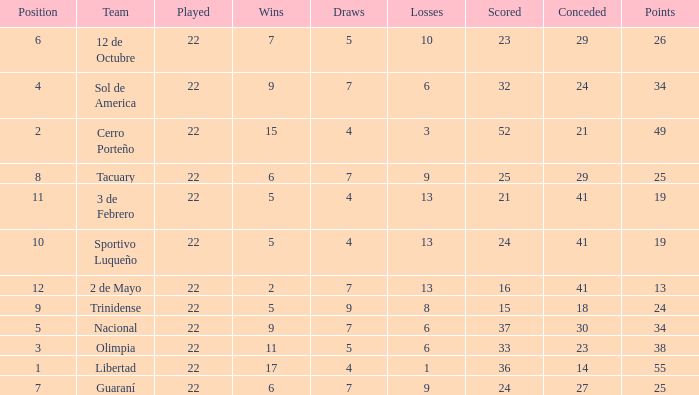What is the number of draws for the team with more than 8 losses and 13 points? 7.0. 